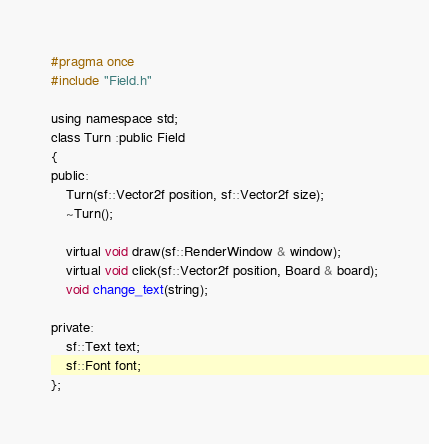<code> <loc_0><loc_0><loc_500><loc_500><_C_>#pragma once
#include "Field.h"

using namespace std;
class Turn :public Field
{
public:
	Turn(sf::Vector2f position, sf::Vector2f size);
	~Turn();

	virtual void draw(sf::RenderWindow & window);
	virtual void click(sf::Vector2f position, Board & board);
	void change_text(string);

private:
	sf::Text text;
	sf::Font font;
};

</code> 